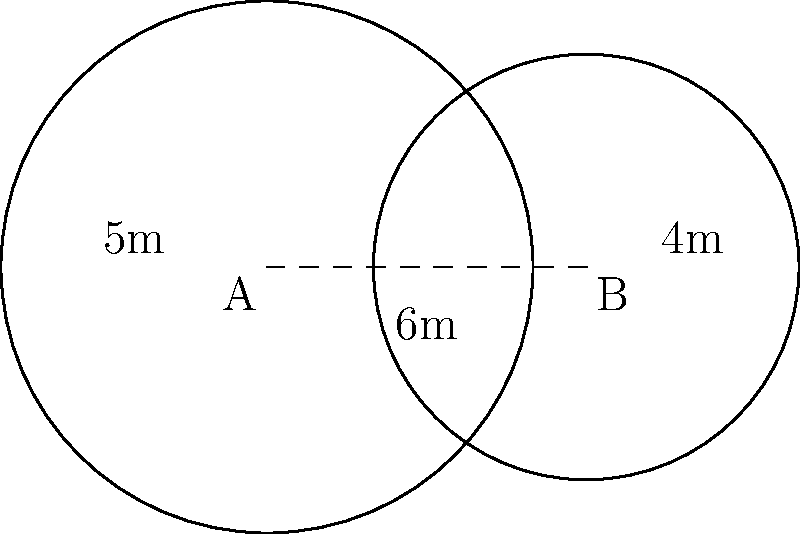You're exploring an ancient Scottish site with two circular standing stones. The stones are represented by circles A and B in the diagram. Circle A has a radius of 5 meters, and circle B has a radius of 4 meters. The centers of the circles are 6 meters apart. Calculate the area of overlap between these two standing stones to the nearest square meter. Let's solve this step-by-step:

1) First, we need to find the distance from the center of each circle to the line where they intersect. Let's call these distances $x$ and $y$ for circles A and B respectively.

2) We can use the Pythagorean theorem:

   $x^2 + y^2 = 6^2$
   $5^2 - x^2 = 4^2 - y^2$

3) Solving these equations:
   $x = 3.4$ meters
   $y = 2.6$ meters

4) Now we can find the central angle for each circle:
   
   For A: $\theta_A = 2 \arccos(\frac{3.4}{5}) = 2.214$ radians
   For B: $\theta_B = 2 \arccos(\frac{2.6}{4}) = 2.498$ radians

5) The area of a circular sector is given by $\frac{1}{2}r^2\theta$, where $r$ is the radius and $\theta$ is the central angle in radians.

6) The area of the triangle in each sector is $\frac{1}{2}r^2\sin(\theta)$

7) The area of overlap for each circle is the difference between its sector and triangle:

   For A: $\frac{1}{2}(5^2)(2.214) - \frac{1}{2}(5^2)\sin(2.214) = 13.84 - 8.37 = 5.47$ sq meters
   For B: $\frac{1}{2}(4^2)(2.498) - \frac{1}{2}(4^2)\sin(2.498) = 9.99 - 6.24 = 3.75$ sq meters

8) The total area of overlap is the sum of these two: $5.47 + 3.75 = 9.22$ sq meters

9) Rounding to the nearest square meter: 9 sq meters
Answer: 9 square meters 